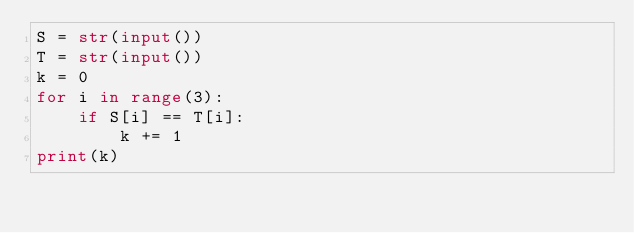<code> <loc_0><loc_0><loc_500><loc_500><_Python_>S = str(input())
T = str(input())
k = 0
for i in range(3):
    if S[i] == T[i]:
        k += 1
print(k)
</code> 